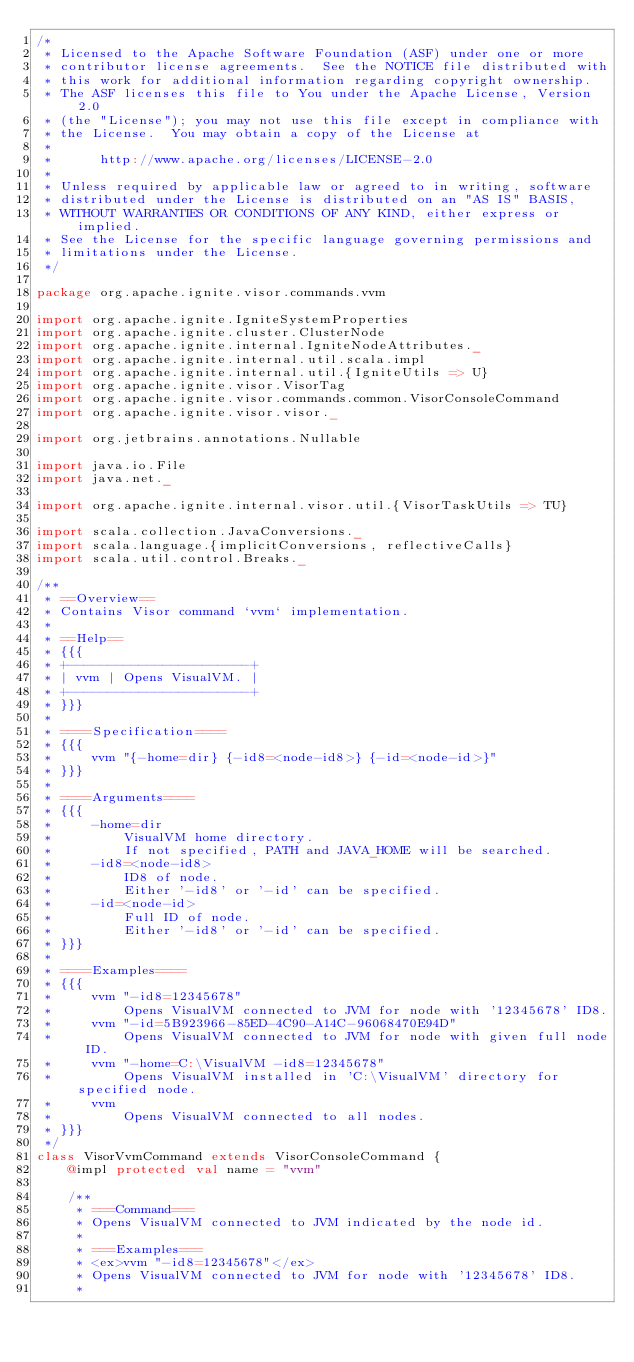Convert code to text. <code><loc_0><loc_0><loc_500><loc_500><_Scala_>/*
 * Licensed to the Apache Software Foundation (ASF) under one or more
 * contributor license agreements.  See the NOTICE file distributed with
 * this work for additional information regarding copyright ownership.
 * The ASF licenses this file to You under the Apache License, Version 2.0
 * (the "License"); you may not use this file except in compliance with
 * the License.  You may obtain a copy of the License at
 *
 *      http://www.apache.org/licenses/LICENSE-2.0
 *
 * Unless required by applicable law or agreed to in writing, software
 * distributed under the License is distributed on an "AS IS" BASIS,
 * WITHOUT WARRANTIES OR CONDITIONS OF ANY KIND, either express or implied.
 * See the License for the specific language governing permissions and
 * limitations under the License.
 */

package org.apache.ignite.visor.commands.vvm

import org.apache.ignite.IgniteSystemProperties
import org.apache.ignite.cluster.ClusterNode
import org.apache.ignite.internal.IgniteNodeAttributes._
import org.apache.ignite.internal.util.scala.impl
import org.apache.ignite.internal.util.{IgniteUtils => U}
import org.apache.ignite.visor.VisorTag
import org.apache.ignite.visor.commands.common.VisorConsoleCommand
import org.apache.ignite.visor.visor._

import org.jetbrains.annotations.Nullable

import java.io.File
import java.net._

import org.apache.ignite.internal.visor.util.{VisorTaskUtils => TU}

import scala.collection.JavaConversions._
import scala.language.{implicitConversions, reflectiveCalls}
import scala.util.control.Breaks._

/**
 * ==Overview==
 * Contains Visor command `vvm` implementation.
 *
 * ==Help==
 * {{{
 * +-----------------------+
 * | vvm | Opens VisualVM. |
 * +-----------------------+
 * }}}
 *
 * ====Specification====
 * {{{
 *     vvm "{-home=dir} {-id8=<node-id8>} {-id=<node-id>}"
 * }}}
 *
 * ====Arguments====
 * {{{
 *     -home=dir
 *         VisualVM home directory.
 *         If not specified, PATH and JAVA_HOME will be searched.
 *     -id8=<node-id8>
 *         ID8 of node.
 *         Either '-id8' or '-id' can be specified.
 *     -id=<node-id>
 *         Full ID of node.
 *         Either '-id8' or '-id' can be specified.
 * }}}
 *
 * ====Examples====
 * {{{
 *     vvm "-id8=12345678"
 *         Opens VisualVM connected to JVM for node with '12345678' ID8.
 *     vvm "-id=5B923966-85ED-4C90-A14C-96068470E94D"
 *         Opens VisualVM connected to JVM for node with given full node ID.
 *     vvm "-home=C:\VisualVM -id8=12345678"
 *         Opens VisualVM installed in 'C:\VisualVM' directory for specified node.
 *     vvm
 *         Opens VisualVM connected to all nodes.
 * }}}
 */
class VisorVvmCommand extends VisorConsoleCommand {
    @impl protected val name = "vvm"

    /**
     * ===Command===
     * Opens VisualVM connected to JVM indicated by the node id.
     *
     * ===Examples===
     * <ex>vvm "-id8=12345678"</ex>
     * Opens VisualVM connected to JVM for node with '12345678' ID8.
     *</code> 